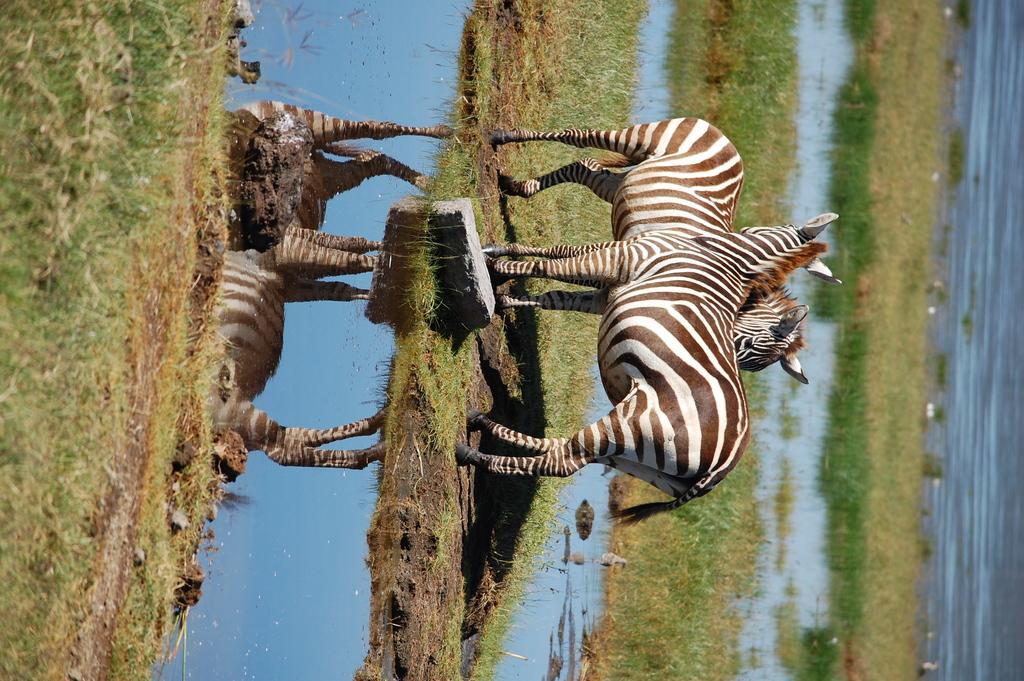Please provide a concise description of this image. In this picture I can see zebras on the surface. I can see green grass. I can see water. 